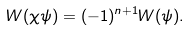Convert formula to latex. <formula><loc_0><loc_0><loc_500><loc_500>W ( \chi \psi ) = ( - 1 ) ^ { n + 1 } W ( \psi ) .</formula> 